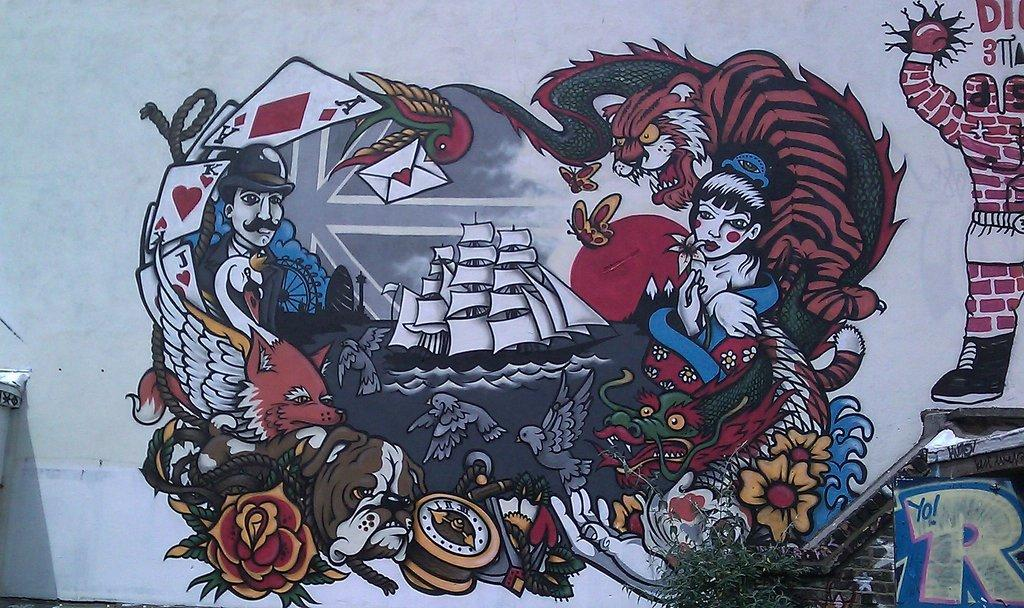What is present on the wall in the image? There is a painting on the wall in the image. What else can be seen on the wall? The painting is the only visible object on the wall. What type of vegetation is visible in the image? Leaves are visible in the image. What type of body is depicted in the painting on the wall? There is no body depicted in the painting on the wall; the painting's subject cannot be determined from the image. 